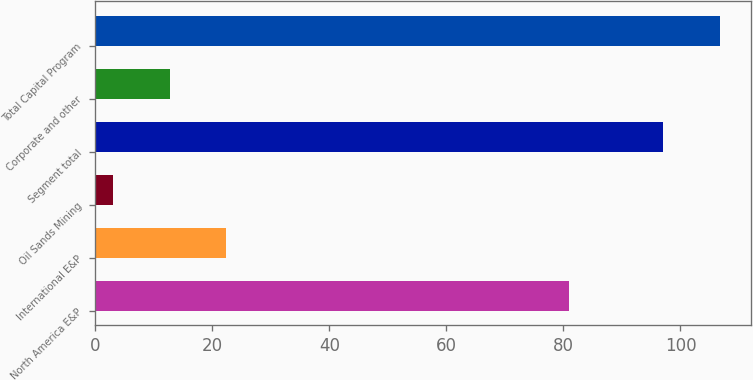<chart> <loc_0><loc_0><loc_500><loc_500><bar_chart><fcel>North America E&P<fcel>International E&P<fcel>Oil Sands Mining<fcel>Segment total<fcel>Corporate and other<fcel>Total Capital Program<nl><fcel>81<fcel>22.4<fcel>3<fcel>97<fcel>12.7<fcel>106.7<nl></chart> 